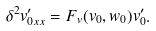Convert formula to latex. <formula><loc_0><loc_0><loc_500><loc_500>\delta ^ { 2 } v _ { 0 x x } ^ { \prime } = F _ { v } ( v _ { 0 } , w _ { 0 } ) v _ { 0 } ^ { \prime } .</formula> 